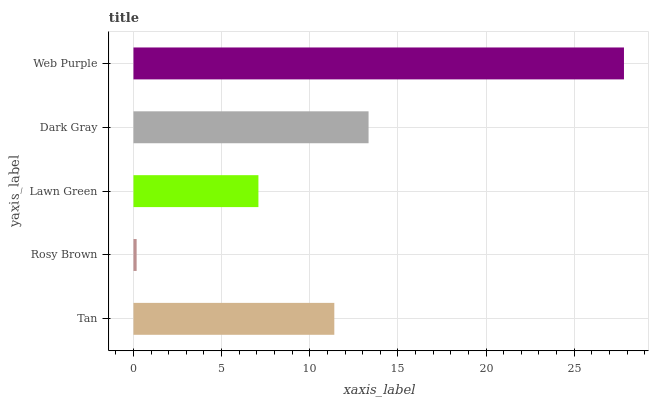Is Rosy Brown the minimum?
Answer yes or no. Yes. Is Web Purple the maximum?
Answer yes or no. Yes. Is Lawn Green the minimum?
Answer yes or no. No. Is Lawn Green the maximum?
Answer yes or no. No. Is Lawn Green greater than Rosy Brown?
Answer yes or no. Yes. Is Rosy Brown less than Lawn Green?
Answer yes or no. Yes. Is Rosy Brown greater than Lawn Green?
Answer yes or no. No. Is Lawn Green less than Rosy Brown?
Answer yes or no. No. Is Tan the high median?
Answer yes or no. Yes. Is Tan the low median?
Answer yes or no. Yes. Is Dark Gray the high median?
Answer yes or no. No. Is Rosy Brown the low median?
Answer yes or no. No. 